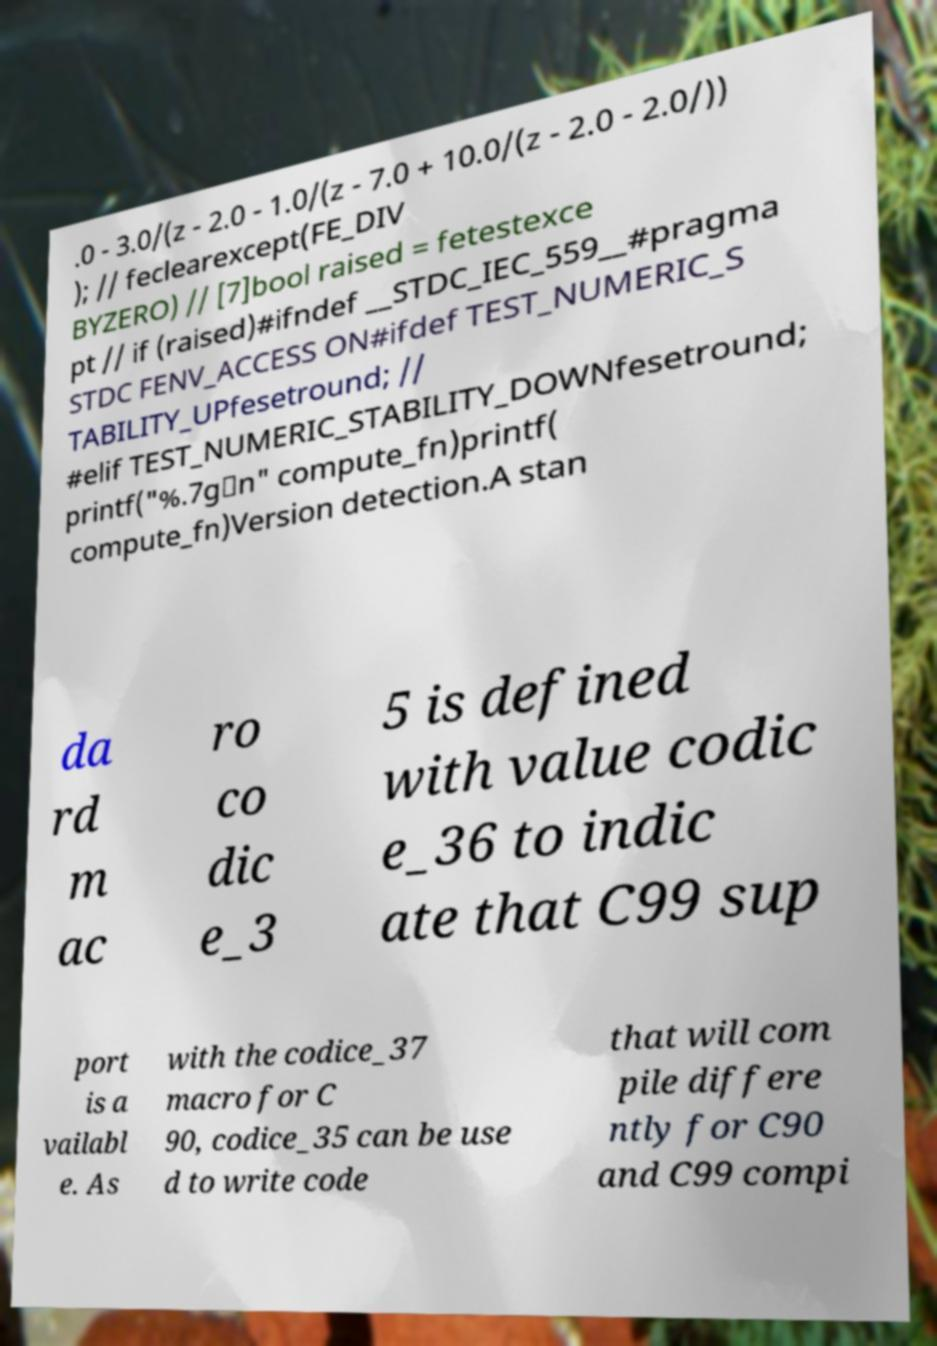Could you extract and type out the text from this image? .0 - 3.0/(z - 2.0 - 1.0/(z - 7.0 + 10.0/(z - 2.0 - 2.0/)) ); // feclearexcept(FE_DIV BYZERO) // [7]bool raised = fetestexce pt // if (raised)#ifndef __STDC_IEC_559__#pragma STDC FENV_ACCESS ON#ifdef TEST_NUMERIC_S TABILITY_UPfesetround; // #elif TEST_NUMERIC_STABILITY_DOWNfesetround; printf("%.7g\n" compute_fn)printf( compute_fn)Version detection.A stan da rd m ac ro co dic e_3 5 is defined with value codic e_36 to indic ate that C99 sup port is a vailabl e. As with the codice_37 macro for C 90, codice_35 can be use d to write code that will com pile differe ntly for C90 and C99 compi 